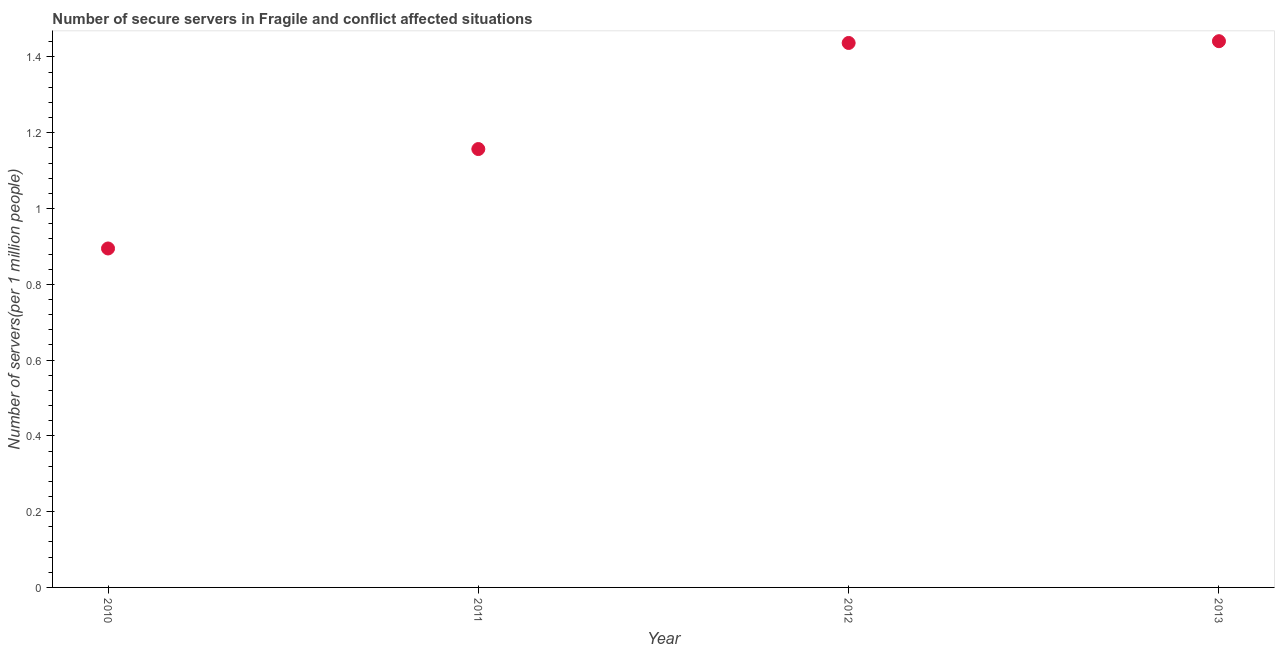What is the number of secure internet servers in 2011?
Offer a terse response. 1.16. Across all years, what is the maximum number of secure internet servers?
Keep it short and to the point. 1.44. Across all years, what is the minimum number of secure internet servers?
Your answer should be very brief. 0.89. In which year was the number of secure internet servers maximum?
Provide a succinct answer. 2013. What is the sum of the number of secure internet servers?
Provide a succinct answer. 4.93. What is the difference between the number of secure internet servers in 2010 and 2013?
Make the answer very short. -0.55. What is the average number of secure internet servers per year?
Offer a very short reply. 1.23. What is the median number of secure internet servers?
Give a very brief answer. 1.3. In how many years, is the number of secure internet servers greater than 1.3200000000000003 ?
Your response must be concise. 2. Do a majority of the years between 2011 and 2010 (inclusive) have number of secure internet servers greater than 1.3200000000000003 ?
Your response must be concise. No. What is the ratio of the number of secure internet servers in 2011 to that in 2012?
Give a very brief answer. 0.81. Is the number of secure internet servers in 2010 less than that in 2011?
Provide a short and direct response. Yes. Is the difference between the number of secure internet servers in 2010 and 2013 greater than the difference between any two years?
Provide a succinct answer. Yes. What is the difference between the highest and the second highest number of secure internet servers?
Offer a terse response. 0. What is the difference between the highest and the lowest number of secure internet servers?
Your answer should be compact. 0.55. In how many years, is the number of secure internet servers greater than the average number of secure internet servers taken over all years?
Make the answer very short. 2. Does the number of secure internet servers monotonically increase over the years?
Your answer should be compact. Yes. How many years are there in the graph?
Your answer should be very brief. 4. What is the difference between two consecutive major ticks on the Y-axis?
Offer a terse response. 0.2. Does the graph contain any zero values?
Your response must be concise. No. Does the graph contain grids?
Provide a succinct answer. No. What is the title of the graph?
Make the answer very short. Number of secure servers in Fragile and conflict affected situations. What is the label or title of the Y-axis?
Provide a succinct answer. Number of servers(per 1 million people). What is the Number of servers(per 1 million people) in 2010?
Your response must be concise. 0.89. What is the Number of servers(per 1 million people) in 2011?
Offer a very short reply. 1.16. What is the Number of servers(per 1 million people) in 2012?
Provide a succinct answer. 1.44. What is the Number of servers(per 1 million people) in 2013?
Your answer should be very brief. 1.44. What is the difference between the Number of servers(per 1 million people) in 2010 and 2011?
Your answer should be compact. -0.26. What is the difference between the Number of servers(per 1 million people) in 2010 and 2012?
Your answer should be compact. -0.54. What is the difference between the Number of servers(per 1 million people) in 2010 and 2013?
Provide a succinct answer. -0.55. What is the difference between the Number of servers(per 1 million people) in 2011 and 2012?
Your answer should be compact. -0.28. What is the difference between the Number of servers(per 1 million people) in 2011 and 2013?
Your response must be concise. -0.28. What is the difference between the Number of servers(per 1 million people) in 2012 and 2013?
Provide a succinct answer. -0. What is the ratio of the Number of servers(per 1 million people) in 2010 to that in 2011?
Your answer should be very brief. 0.77. What is the ratio of the Number of servers(per 1 million people) in 2010 to that in 2012?
Keep it short and to the point. 0.62. What is the ratio of the Number of servers(per 1 million people) in 2010 to that in 2013?
Keep it short and to the point. 0.62. What is the ratio of the Number of servers(per 1 million people) in 2011 to that in 2012?
Provide a short and direct response. 0.81. What is the ratio of the Number of servers(per 1 million people) in 2011 to that in 2013?
Your answer should be compact. 0.8. 